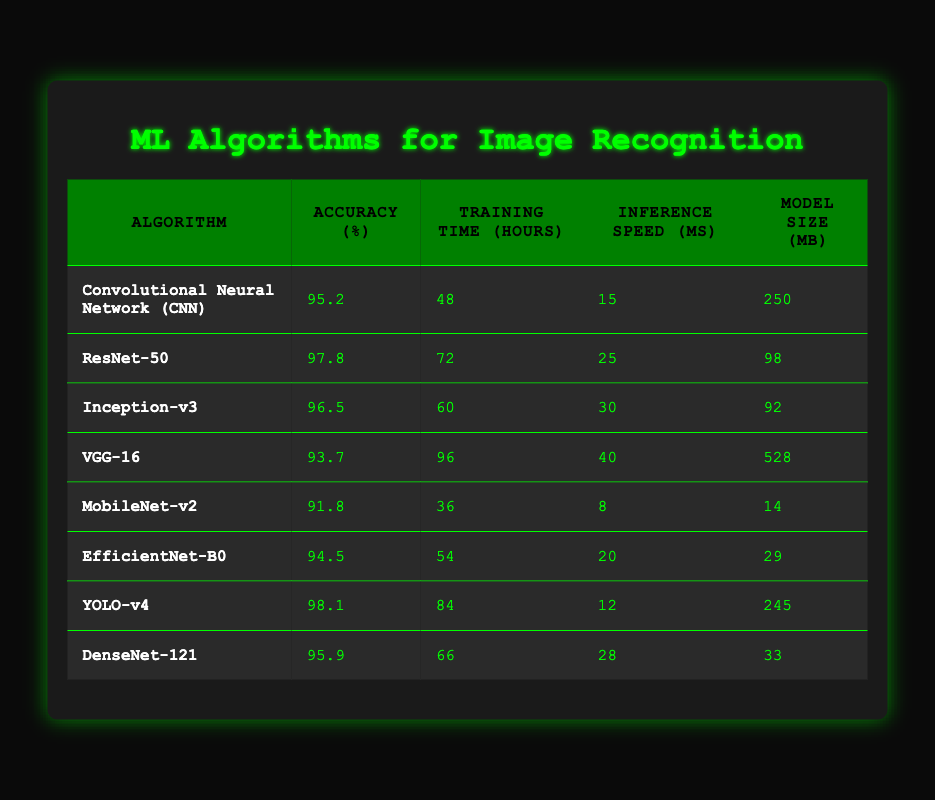What is the highest accuracy achieved by any algorithm in the table? The highest accuracy listed in the table is 98.1%, which is achieved by the YOLO-v4 algorithm.
Answer: 98.1% How many hours does it take to train the VGG-16 model? According to the table, the training time for the VGG-16 model is 96 hours.
Answer: 96 hours Which algorithm has the smallest model size? MobileNet-v2 has the smallest model size of 14 MB according to the table.
Answer: 14 MB What is the total training time for ResNet-50 and YOLO-v4? The training times are 72 hours for ResNet-50 and 84 hours for YOLO-v4. Adding these gives 72 + 84 = 156 hours.
Answer: 156 hours Does EfficientNet-B0 have a better inference speed than Inception-v3? EfficientNet-B0 has an inference speed of 20 ms while Inception-v3 has 30 ms. Since 20 ms is less than 30 ms, the statement is true.
Answer: Yes Which algorithm has both high accuracy and a relatively low model size? EfficientNet-B0 has an accuracy of 94.5% and a model size of 29 MB, which are both favorable compared to others, particularly VGG-16 which has high accuracy but a large model size.
Answer: EfficientNet-B0 What is the average accuracy of the algorithms listed in the table? The total accuracy values are 95.2 + 97.8 + 96.5 + 93.7 + 91.8 + 94.5 + 98.1 + 95.9 =  95.5% and there are 8 algorithms, so the average is  95.5 / 8 = 95.6875%.
Answer: 95.7% Which algorithm has the lowest accuracy, and what is that accuracy? The algorithm with the lowest accuracy is MobileNet-v2 with an accuracy of 91.8%.
Answer: MobileNet-v2, 91.8% Is it true that the Inception-v3 model has a longer training time than the MobileNet-v2? Inception-v3 requires 60 hours of training, while MobileNet-v2 requires only 36 hours. Therefore, the statement is false.
Answer: No 